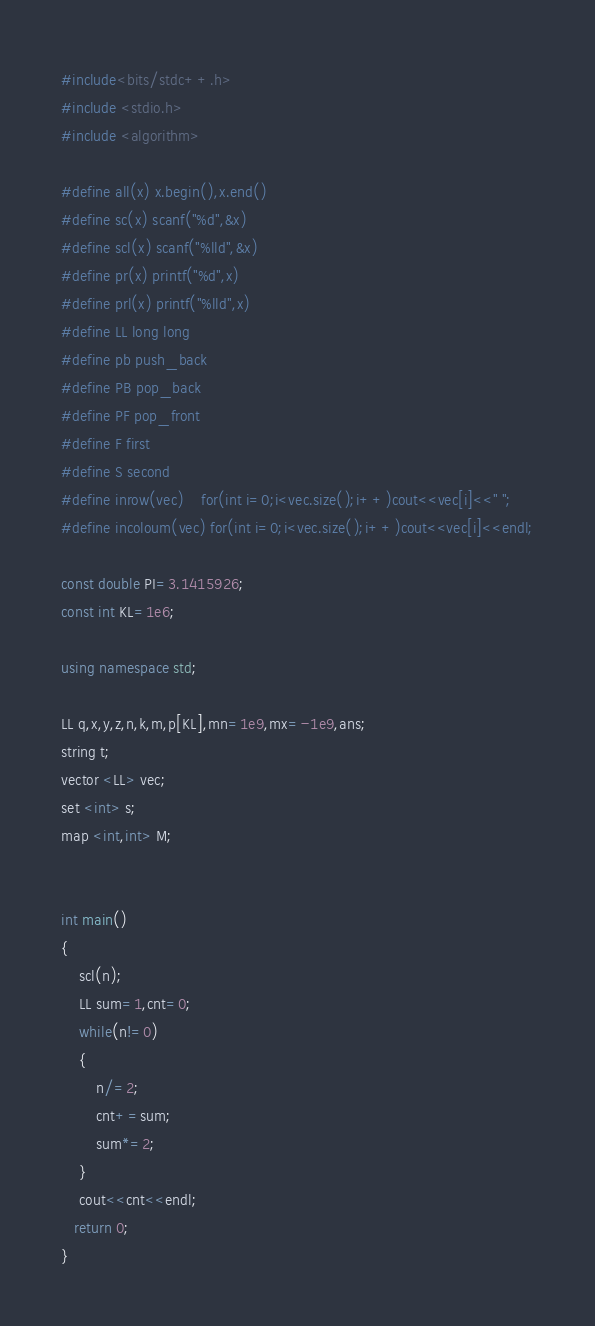Convert code to text. <code><loc_0><loc_0><loc_500><loc_500><_C++_>#include<bits/stdc++.h>
#include <stdio.h>
#include <algorithm>

#define all(x) x.begin(),x.end()
#define sc(x) scanf("%d",&x)
#define scl(x) scanf("%lld",&x)
#define pr(x) printf("%d",x)
#define prl(x) printf("%lld",x)
#define LL long long
#define pb push_back
#define PB pop_back
#define PF pop_front
#define F first
#define S second
#define inrow(vec)    for(int i=0;i<vec.size();i++)cout<<vec[i]<<" ";
#define incoloum(vec) for(int i=0;i<vec.size();i++)cout<<vec[i]<<endl;

const double PI=3.1415926;
const int KL=1e6;

using namespace std;

LL q,x,y,z,n,k,m,p[KL],mn=1e9,mx=-1e9,ans;
string t;
vector <LL> vec;
set <int> s;
map <int,int> M;


int main()
{
    scl(n);
    LL sum=1,cnt=0;
    while(n!=0)
    {
        n/=2;
        cnt+=sum;
        sum*=2;
    }
    cout<<cnt<<endl;
   return 0;
}
</code> 